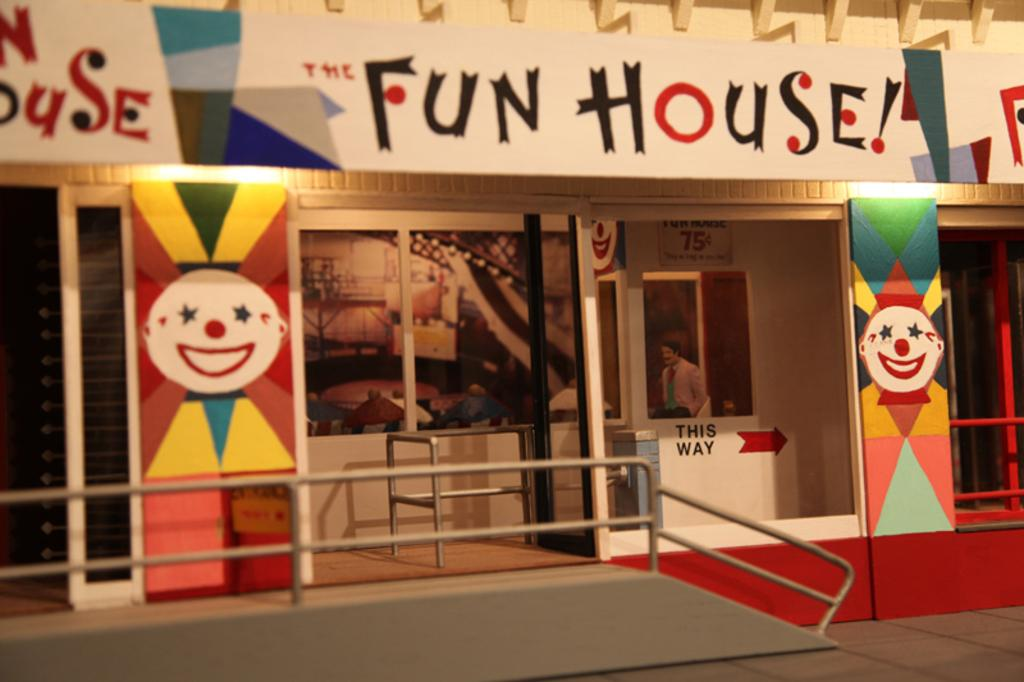<image>
Share a concise interpretation of the image provided. The building in the background is called the Fun House 